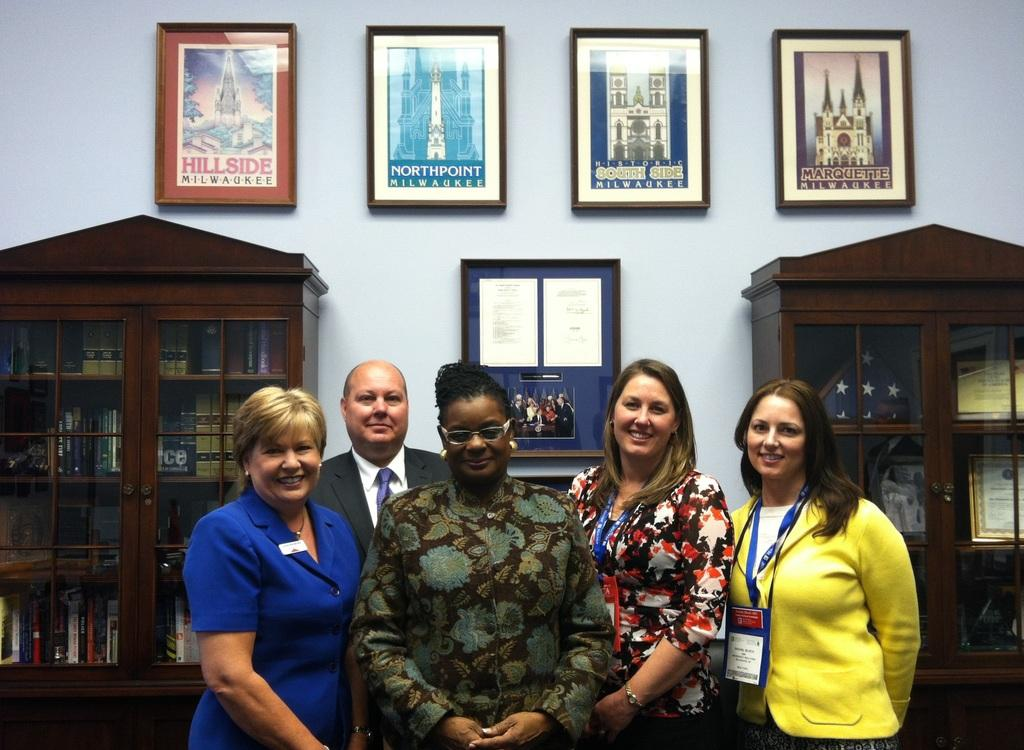What type of furniture is present in the image? The image contains cupboards. What is placed on top of the cupboards? There are photo frames at the top of the cupboards. Can you describe the people in the image? There are people standing in the image, and four of them are women, while one is a man. What type of dinner is being prepared in the image? There is no indication of a dinner being prepared in the image. Can you see a plane in the image? There is no plane present in the image. 